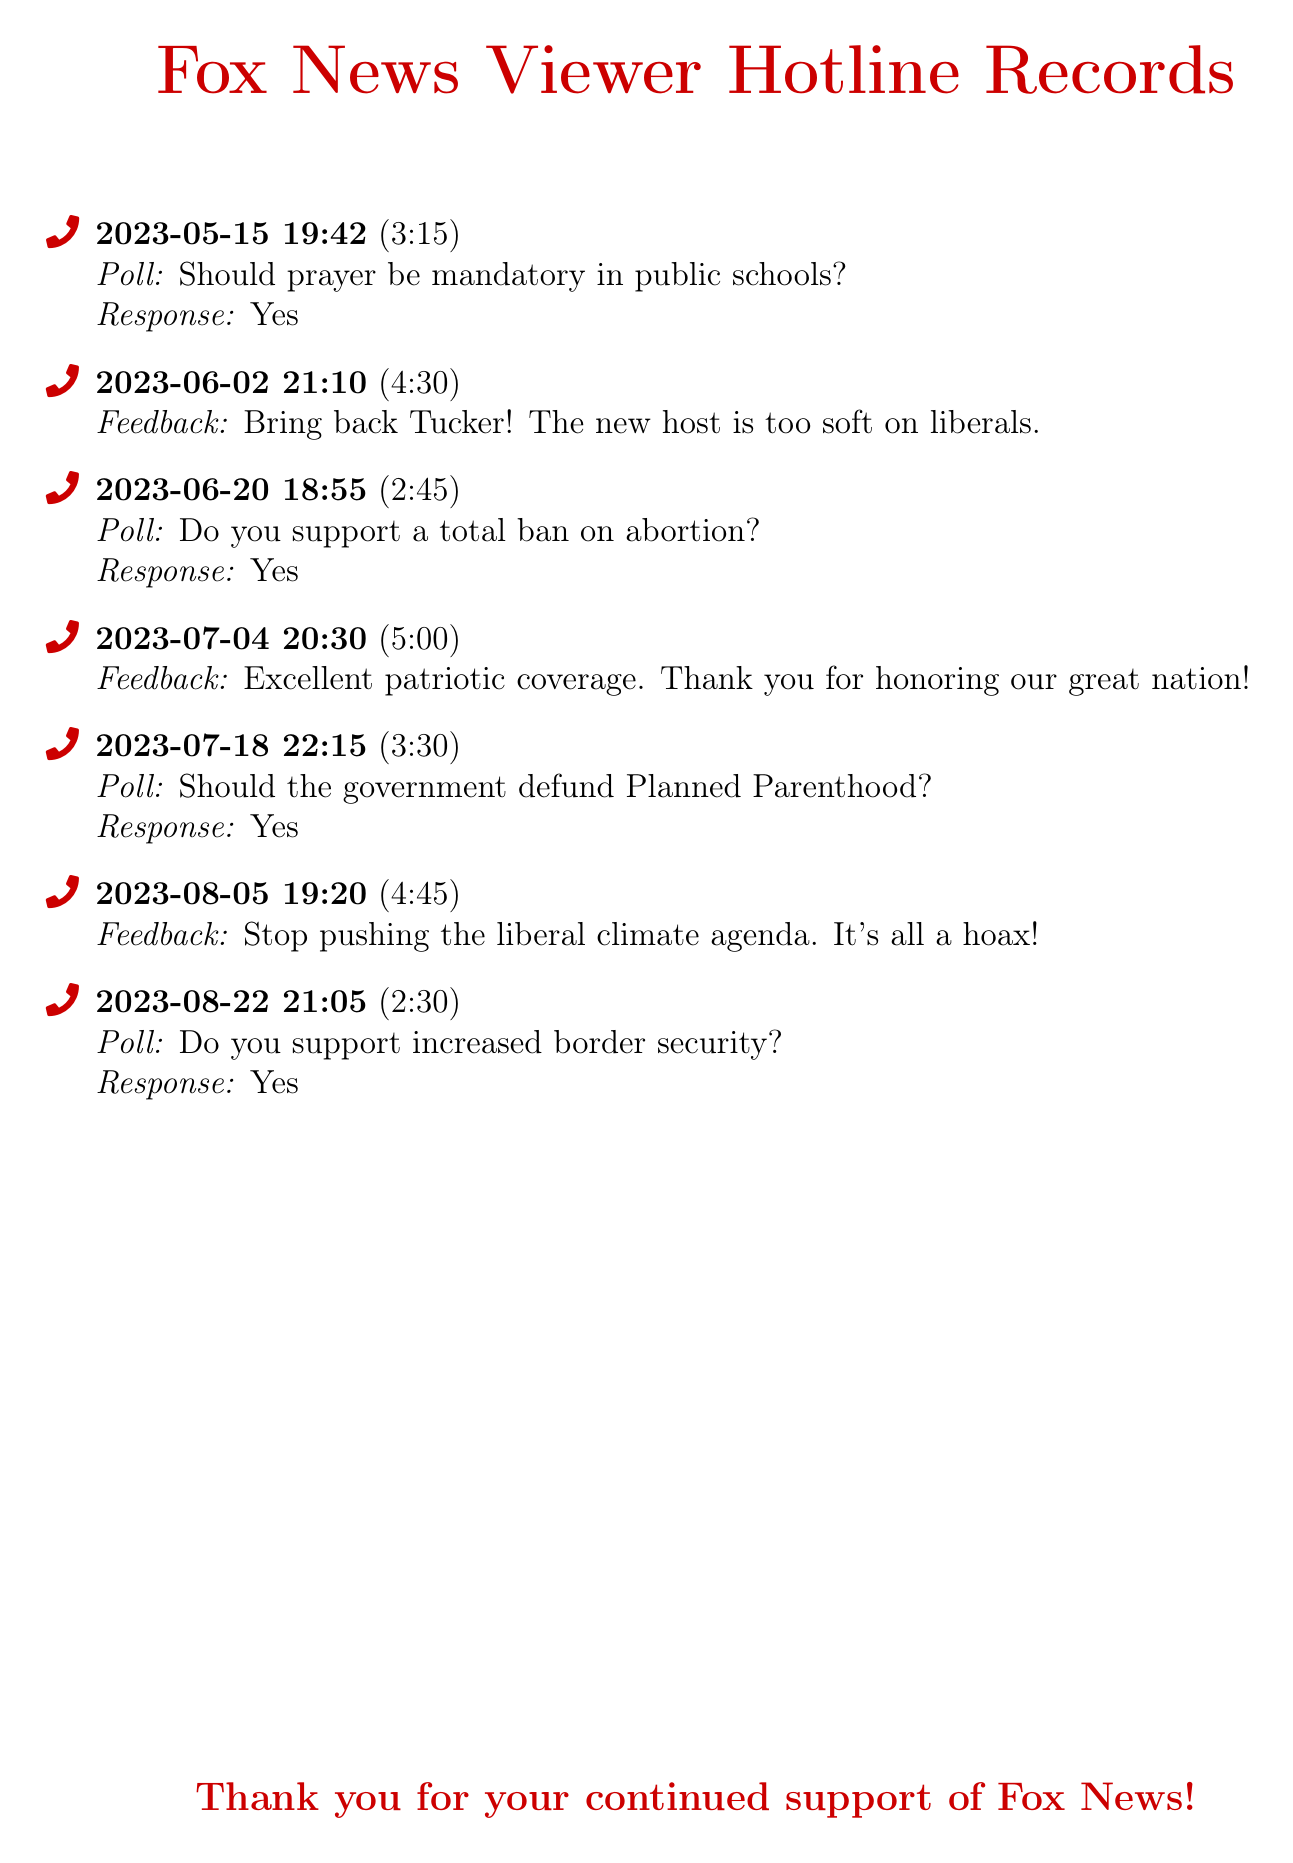what is the date of the first call? The first call listed in the document took place on May 15, 2023.
Answer: May 15, 2023 how long was the third call? The duration of the third call is stated in the document as 2 minutes and 45 seconds.
Answer: 2:45 what was the response to the abortion poll on June 20? The response provided for the abortion poll on June 20 is "Yes."
Answer: Yes how many feedback entries are recorded? There are four feedback entries included in the document.
Answer: 4 what question was asked during the call on July 18? The question asked during the call on July 18 was regarding defunding Planned Parenthood.
Answer: Should the government defund Planned Parenthood? which date had a response about border security? The poll concerning border security was conducted on August 22, 2023.
Answer: August 22, 2023 what was the feedback about Tucker Carlson? The feedback mentioned bringing back Tucker due to the new host being too soft.
Answer: Bring back Tucker! what is the duration of the longest call? The longest call listed had a duration of 5 minutes.
Answer: 5:00 